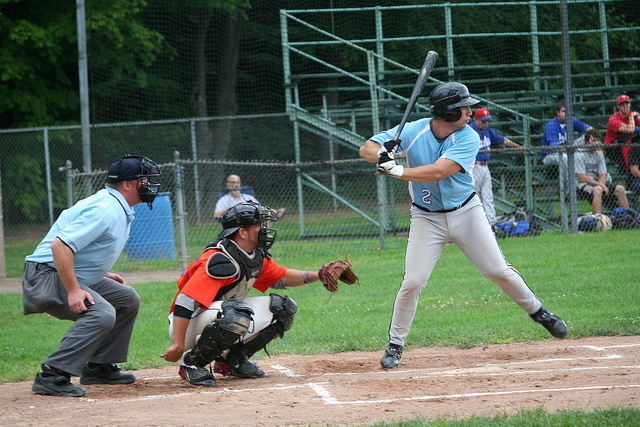Describe the objects in this image and their specific colors. I can see people in darkgreen, black, gray, and lightblue tones, bench in darkgreen, black, and teal tones, people in darkgreen, darkgray, lightgray, lightblue, and black tones, people in darkgreen, black, gray, darkgray, and brown tones, and people in darkgreen, black, maroon, and brown tones in this image. 